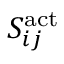Convert formula to latex. <formula><loc_0><loc_0><loc_500><loc_500>S _ { i j } ^ { a c t }</formula> 